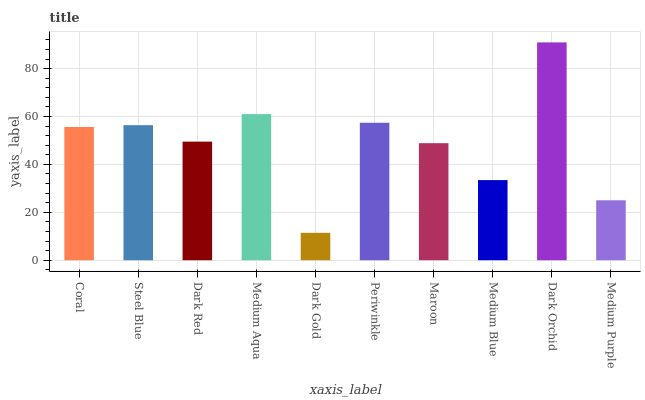Is Dark Gold the minimum?
Answer yes or no. Yes. Is Dark Orchid the maximum?
Answer yes or no. Yes. Is Steel Blue the minimum?
Answer yes or no. No. Is Steel Blue the maximum?
Answer yes or no. No. Is Steel Blue greater than Coral?
Answer yes or no. Yes. Is Coral less than Steel Blue?
Answer yes or no. Yes. Is Coral greater than Steel Blue?
Answer yes or no. No. Is Steel Blue less than Coral?
Answer yes or no. No. Is Coral the high median?
Answer yes or no. Yes. Is Dark Red the low median?
Answer yes or no. Yes. Is Periwinkle the high median?
Answer yes or no. No. Is Coral the low median?
Answer yes or no. No. 